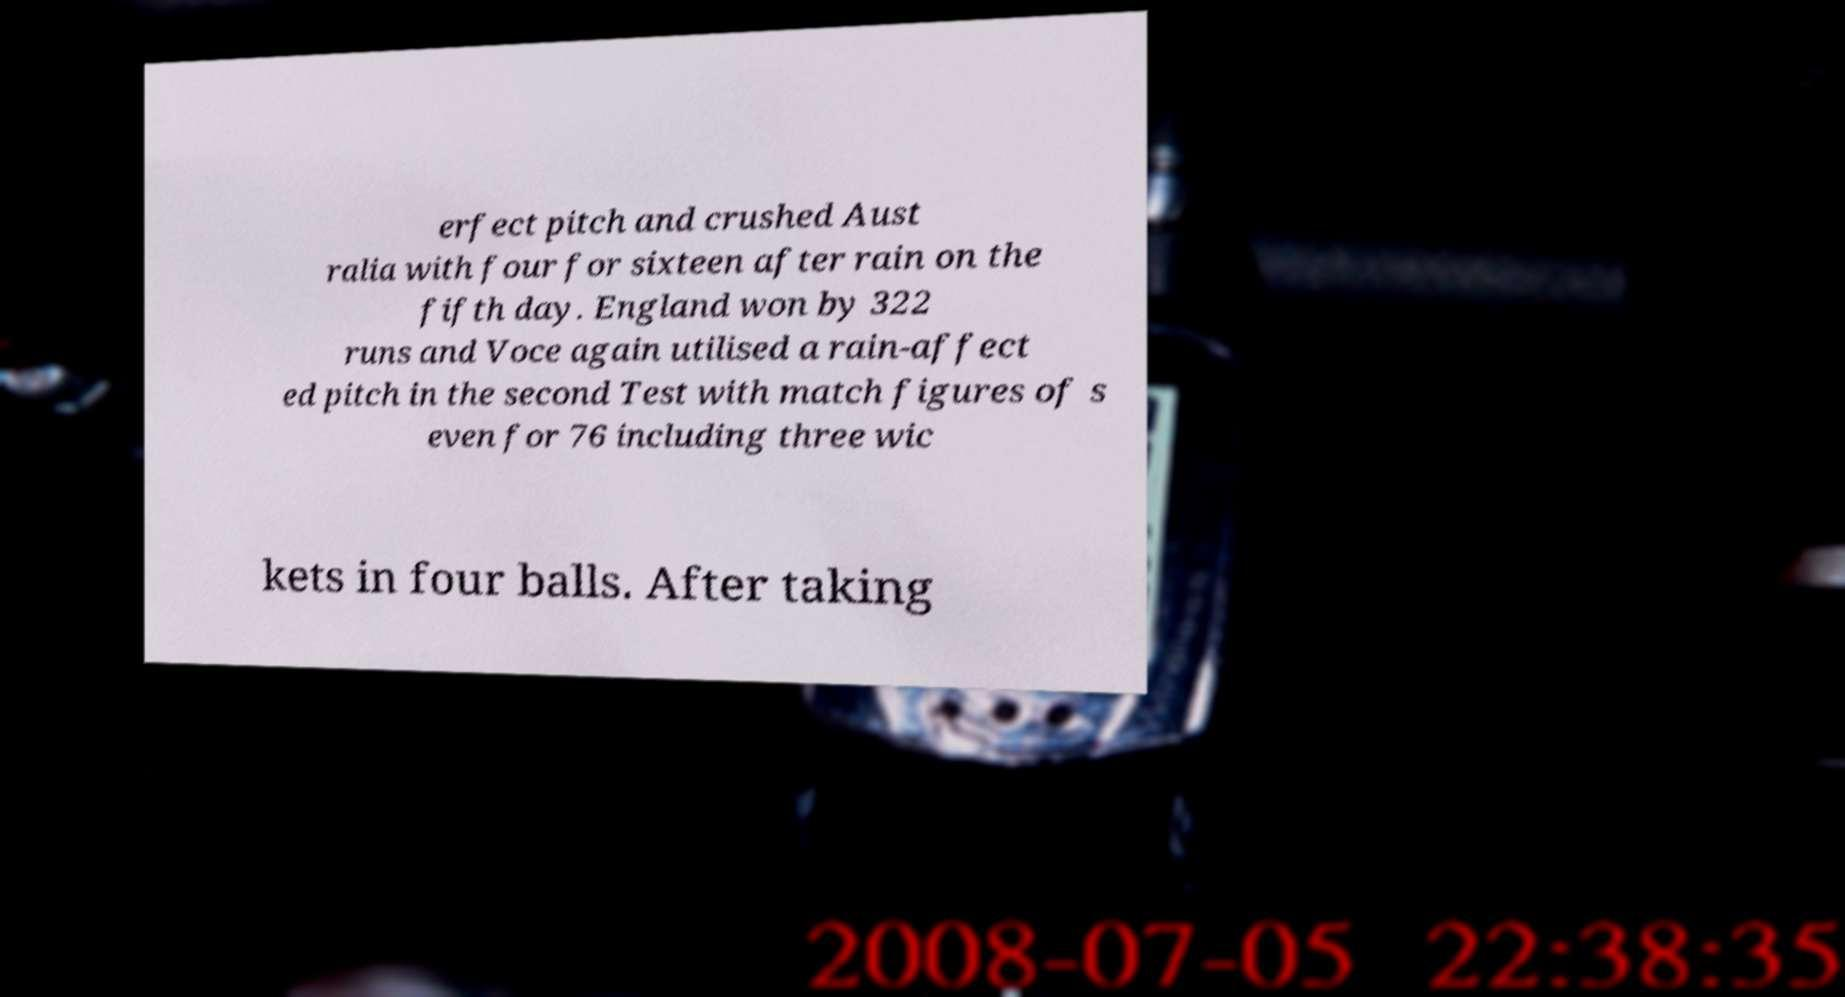Could you assist in decoding the text presented in this image and type it out clearly? erfect pitch and crushed Aust ralia with four for sixteen after rain on the fifth day. England won by 322 runs and Voce again utilised a rain-affect ed pitch in the second Test with match figures of s even for 76 including three wic kets in four balls. After taking 